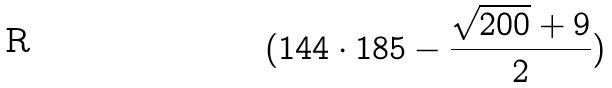Convert formula to latex. <formula><loc_0><loc_0><loc_500><loc_500>( 1 4 4 \cdot 1 8 5 - \frac { \sqrt { 2 0 0 } + 9 } { 2 } )</formula> 